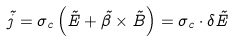<formula> <loc_0><loc_0><loc_500><loc_500>\vec { j } = \sigma _ { c } \left ( \vec { E } + \vec { \beta } \times \vec { B } \right ) = \sigma _ { c } \cdot \delta \vec { E }</formula> 